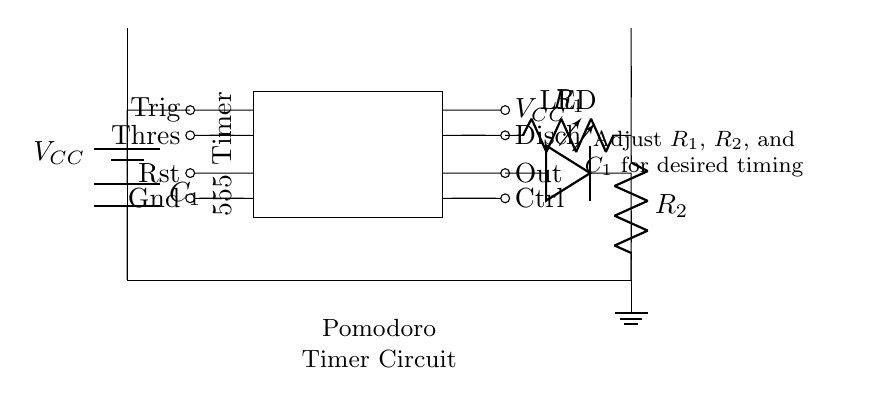What is the main component used for timing in this circuit? The main timing component is the 555 Timer, which functions as an astable multivibrator to create the desired time intervals.
Answer: 555 Timer What is the role of the capacitors in this circuit? The capacitor is used to store charge and determine the timing intervals for the circuit. C1 is charged and discharged, which helps control the timing of the Pomodoro sessions.
Answer: Timing What resistors are present in the circuit? The circuit contains R1 and R2, which are both resistors connected in series. Their values help set the timing interval along with C1.
Answer: R1, R2 How is the LED used in this circuit? The LED indicates when the timer output is active, providing a visual signal to the user during the Pomodoro session.
Answer: Indicator What adjustments can be made to change the timing? You can adjust the values of R1, R2, and C1 to change the timing intervals of the timer. Higher resistance or capacitance will increase the time, while lower values will decrease it.
Answer: R1, R2, C1 What is the output pin in the 555 Timer used for? The output pin serves as the control point for powering the LED and signaling when the timer is active, effectively controlling the operation of the circuit.
Answer: Control 